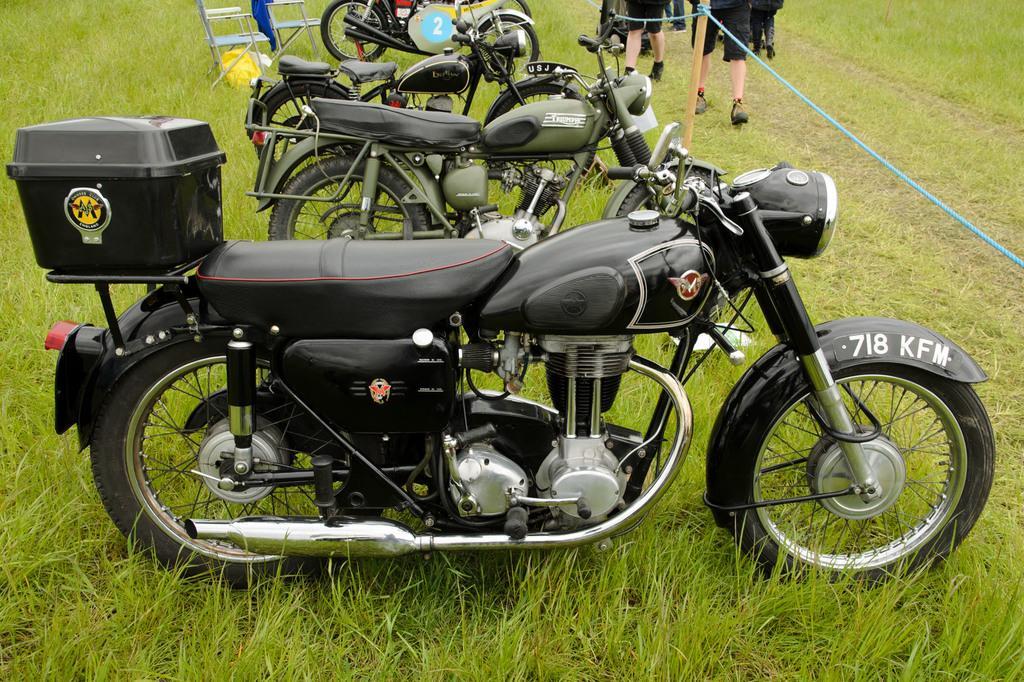Could you give a brief overview of what you see in this image? In the picture we can see a grass surface on it, we can see some bikes are parked and behind it, we can see two chairs and in front of it, we can see some people are walking and a stick and some rope tied to it. 